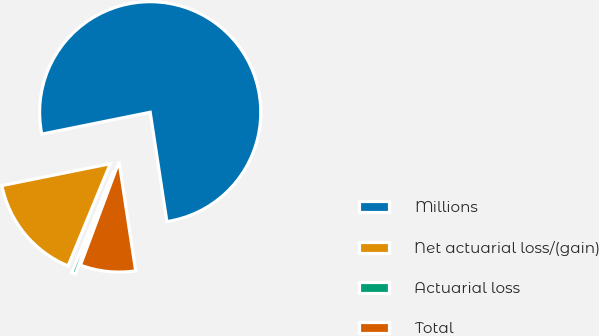Convert chart to OTSL. <chart><loc_0><loc_0><loc_500><loc_500><pie_chart><fcel>Millions<fcel>Net actuarial loss/(gain)<fcel>Actuarial loss<fcel>Total<nl><fcel>75.75%<fcel>15.6%<fcel>0.56%<fcel>8.08%<nl></chart> 